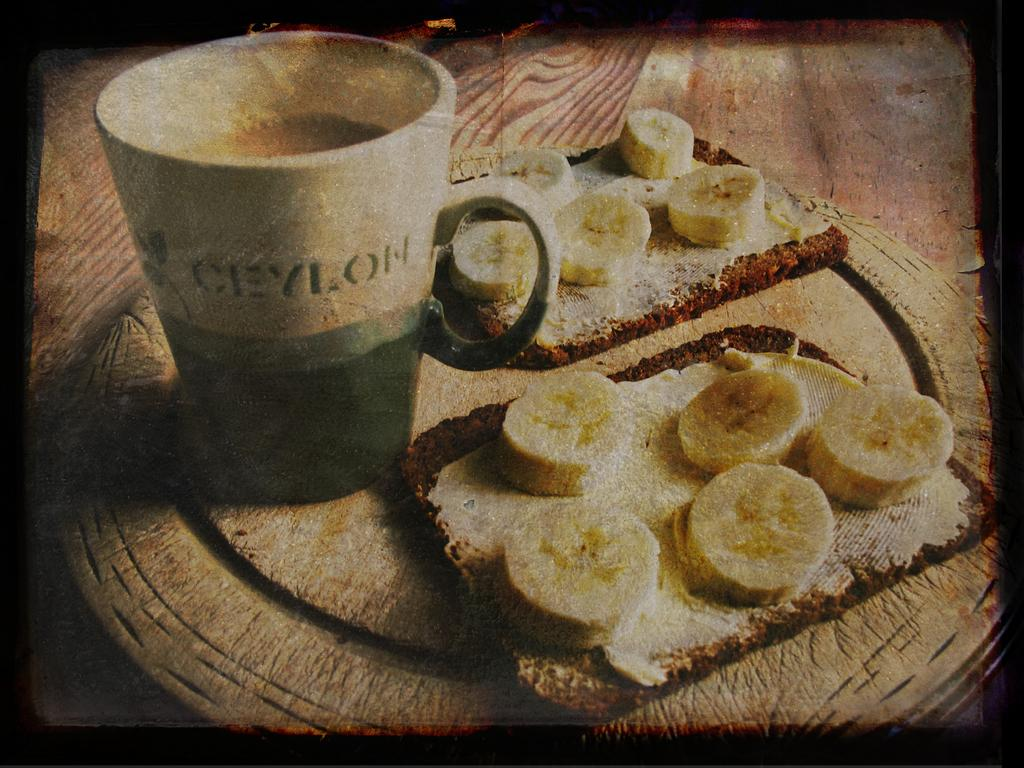What is the main object on the tray in the image? There is a tea mug on the tray in the image. What other food items are on the tray? There is bread and banana slices on the tray. What is the material of the tray? The tray is made of wood. What type of industry is depicted in the image? There is no industry depicted in the image; it features a wooden tray with a tea mug, bread, and banana slices. Can you describe the haircut of the person in the image? There is no person present in the image, so it is not possible to describe their haircut. 